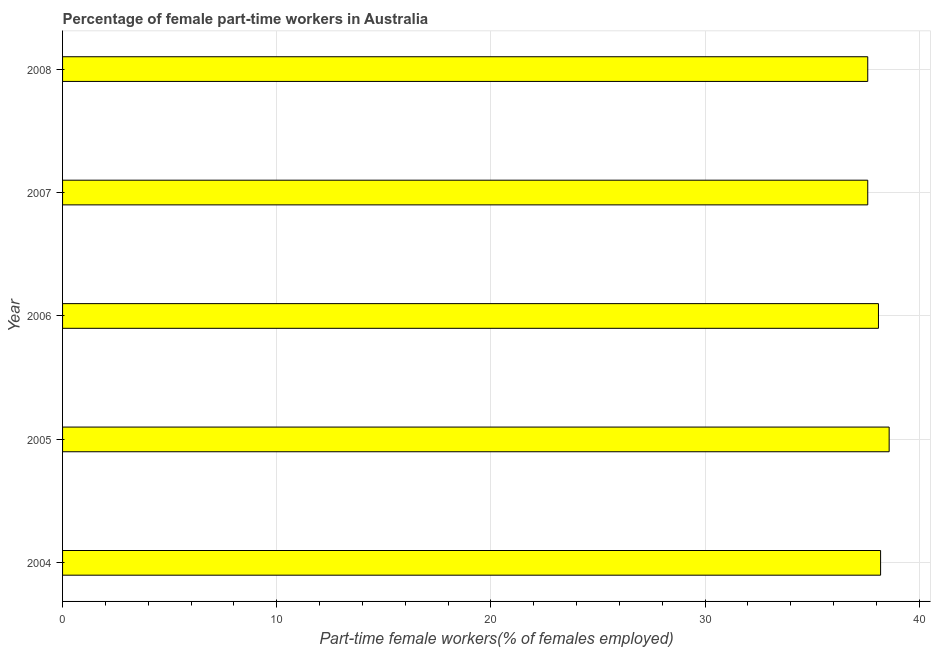Does the graph contain grids?
Provide a succinct answer. Yes. What is the title of the graph?
Your answer should be very brief. Percentage of female part-time workers in Australia. What is the label or title of the X-axis?
Your answer should be very brief. Part-time female workers(% of females employed). What is the percentage of part-time female workers in 2004?
Keep it short and to the point. 38.2. Across all years, what is the maximum percentage of part-time female workers?
Your answer should be very brief. 38.6. Across all years, what is the minimum percentage of part-time female workers?
Offer a terse response. 37.6. In which year was the percentage of part-time female workers maximum?
Offer a terse response. 2005. What is the sum of the percentage of part-time female workers?
Offer a very short reply. 190.1. What is the average percentage of part-time female workers per year?
Your answer should be very brief. 38.02. What is the median percentage of part-time female workers?
Provide a succinct answer. 38.1. In how many years, is the percentage of part-time female workers greater than 6 %?
Ensure brevity in your answer.  5. What is the ratio of the percentage of part-time female workers in 2004 to that in 2006?
Offer a very short reply. 1. Is the percentage of part-time female workers in 2007 less than that in 2008?
Give a very brief answer. No. What is the difference between the highest and the second highest percentage of part-time female workers?
Keep it short and to the point. 0.4. Are all the bars in the graph horizontal?
Offer a very short reply. Yes. How many years are there in the graph?
Offer a very short reply. 5. What is the difference between two consecutive major ticks on the X-axis?
Offer a terse response. 10. Are the values on the major ticks of X-axis written in scientific E-notation?
Ensure brevity in your answer.  No. What is the Part-time female workers(% of females employed) in 2004?
Give a very brief answer. 38.2. What is the Part-time female workers(% of females employed) in 2005?
Your response must be concise. 38.6. What is the Part-time female workers(% of females employed) of 2006?
Make the answer very short. 38.1. What is the Part-time female workers(% of females employed) in 2007?
Your response must be concise. 37.6. What is the Part-time female workers(% of females employed) of 2008?
Provide a short and direct response. 37.6. What is the difference between the Part-time female workers(% of females employed) in 2004 and 2005?
Your answer should be compact. -0.4. What is the difference between the Part-time female workers(% of females employed) in 2004 and 2008?
Keep it short and to the point. 0.6. What is the difference between the Part-time female workers(% of females employed) in 2005 and 2006?
Your response must be concise. 0.5. What is the difference between the Part-time female workers(% of females employed) in 2005 and 2008?
Your response must be concise. 1. What is the difference between the Part-time female workers(% of females employed) in 2006 and 2008?
Give a very brief answer. 0.5. What is the ratio of the Part-time female workers(% of females employed) in 2004 to that in 2005?
Offer a very short reply. 0.99. What is the ratio of the Part-time female workers(% of females employed) in 2004 to that in 2006?
Ensure brevity in your answer.  1. What is the ratio of the Part-time female workers(% of females employed) in 2004 to that in 2008?
Give a very brief answer. 1.02. What is the ratio of the Part-time female workers(% of females employed) in 2005 to that in 2006?
Ensure brevity in your answer.  1.01. What is the ratio of the Part-time female workers(% of females employed) in 2005 to that in 2007?
Give a very brief answer. 1.03. What is the ratio of the Part-time female workers(% of females employed) in 2005 to that in 2008?
Make the answer very short. 1.03. What is the ratio of the Part-time female workers(% of females employed) in 2006 to that in 2008?
Ensure brevity in your answer.  1.01. 